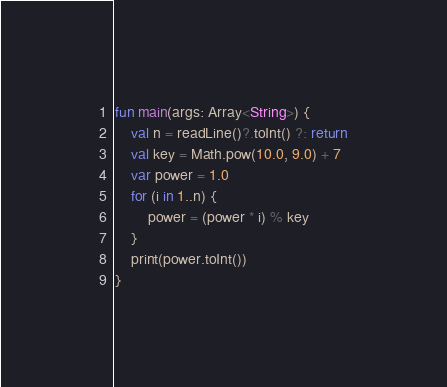Convert code to text. <code><loc_0><loc_0><loc_500><loc_500><_Kotlin_>fun main(args: Array<String>) {
    val n = readLine()?.toInt() ?: return
    val key = Math.pow(10.0, 9.0) + 7
    var power = 1.0
    for (i in 1..n) {
        power = (power * i) % key
    }
    print(power.toInt())
}</code> 